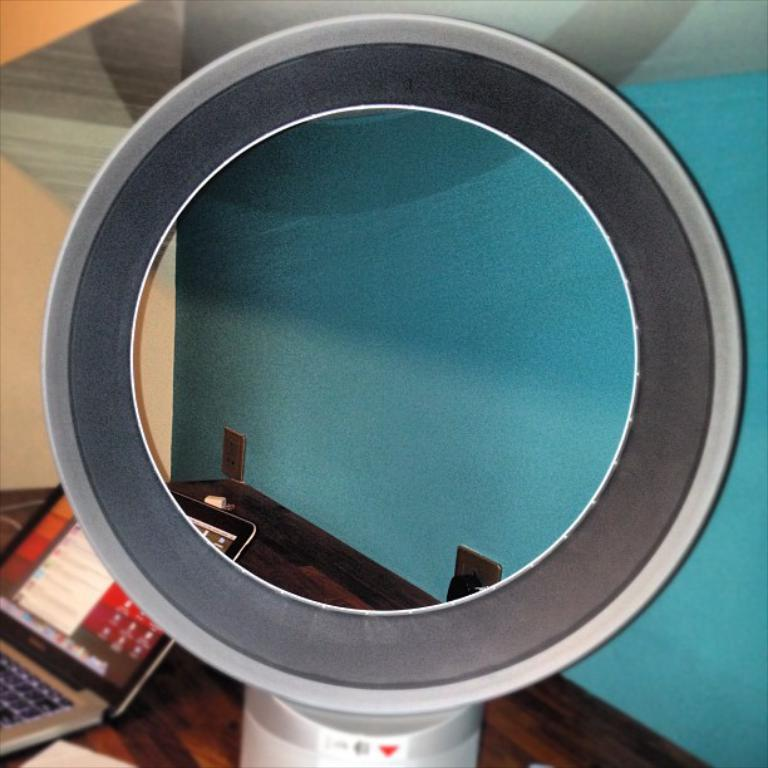What type of table is in the image? There is a wooden table in the image. What electronic device is on the table? A laptop is present on the table. Can you describe the circular object in the image? There is a metal piece of circular shape in the image. What type of whistle can be heard in the image? There is no whistle present in the image, and therefore no sound can be heard. Is there any indication of a war or battle in the image? No, there is no indication of a war or battle in the image. 